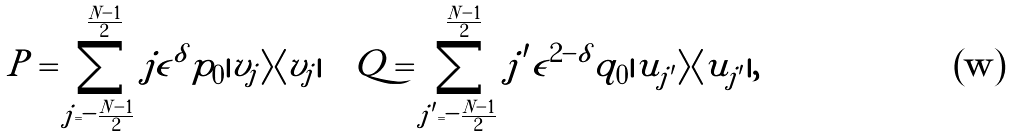Convert formula to latex. <formula><loc_0><loc_0><loc_500><loc_500>P = \sum _ { j = - \frac { N - 1 } 2 } ^ { \frac { N - 1 } 2 } j \epsilon ^ { \delta } p _ { 0 } | v _ { j } \rangle \langle v _ { j } | \quad Q = \sum _ { j ^ { \prime } = - \frac { N - 1 } 2 } ^ { \frac { N - 1 } 2 } j ^ { \prime } \epsilon ^ { 2 - \delta } q _ { 0 } | u _ { j ^ { \prime } } \rangle \langle u _ { j ^ { \prime } } | ,</formula> 